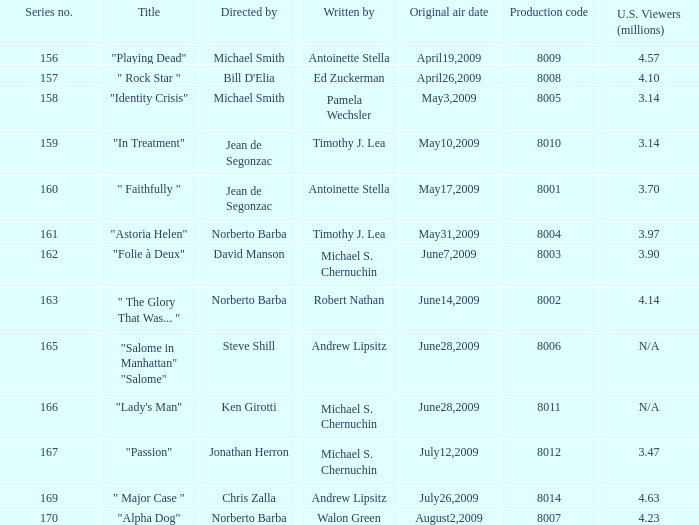Who are the writer of the series episode number 170? Walon Green. 